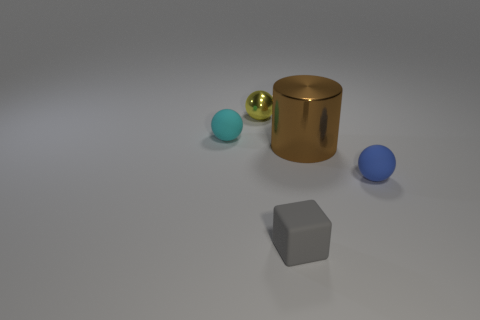What materials are the objects in the image made of? The image shows objects that appear to have different materials. The large cylinder and the two smaller spheres to the left look like they could be metallic due to their shine and reflection. The tiny blue sphere and the larger geometric cube-like object could be made of plastic or some matte material since they don't have reflective properties. 